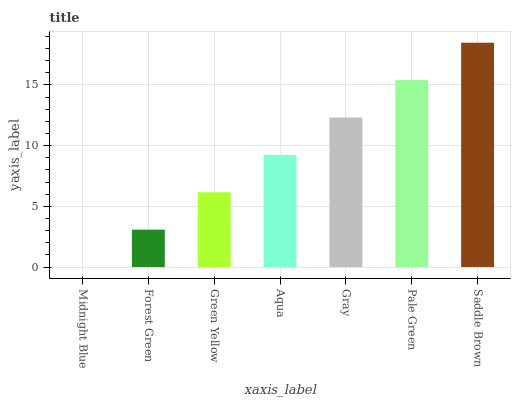Is Midnight Blue the minimum?
Answer yes or no. Yes. Is Saddle Brown the maximum?
Answer yes or no. Yes. Is Forest Green the minimum?
Answer yes or no. No. Is Forest Green the maximum?
Answer yes or no. No. Is Forest Green greater than Midnight Blue?
Answer yes or no. Yes. Is Midnight Blue less than Forest Green?
Answer yes or no. Yes. Is Midnight Blue greater than Forest Green?
Answer yes or no. No. Is Forest Green less than Midnight Blue?
Answer yes or no. No. Is Aqua the high median?
Answer yes or no. Yes. Is Aqua the low median?
Answer yes or no. Yes. Is Saddle Brown the high median?
Answer yes or no. No. Is Green Yellow the low median?
Answer yes or no. No. 